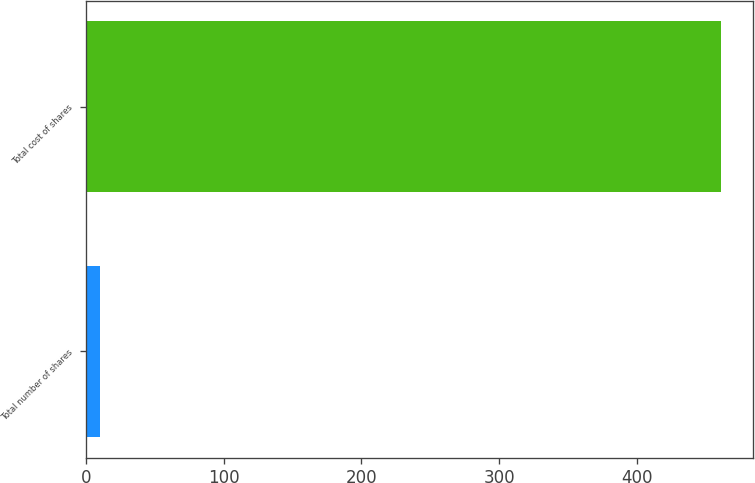<chart> <loc_0><loc_0><loc_500><loc_500><bar_chart><fcel>Total number of shares<fcel>Total cost of shares<nl><fcel>9.8<fcel>461<nl></chart> 